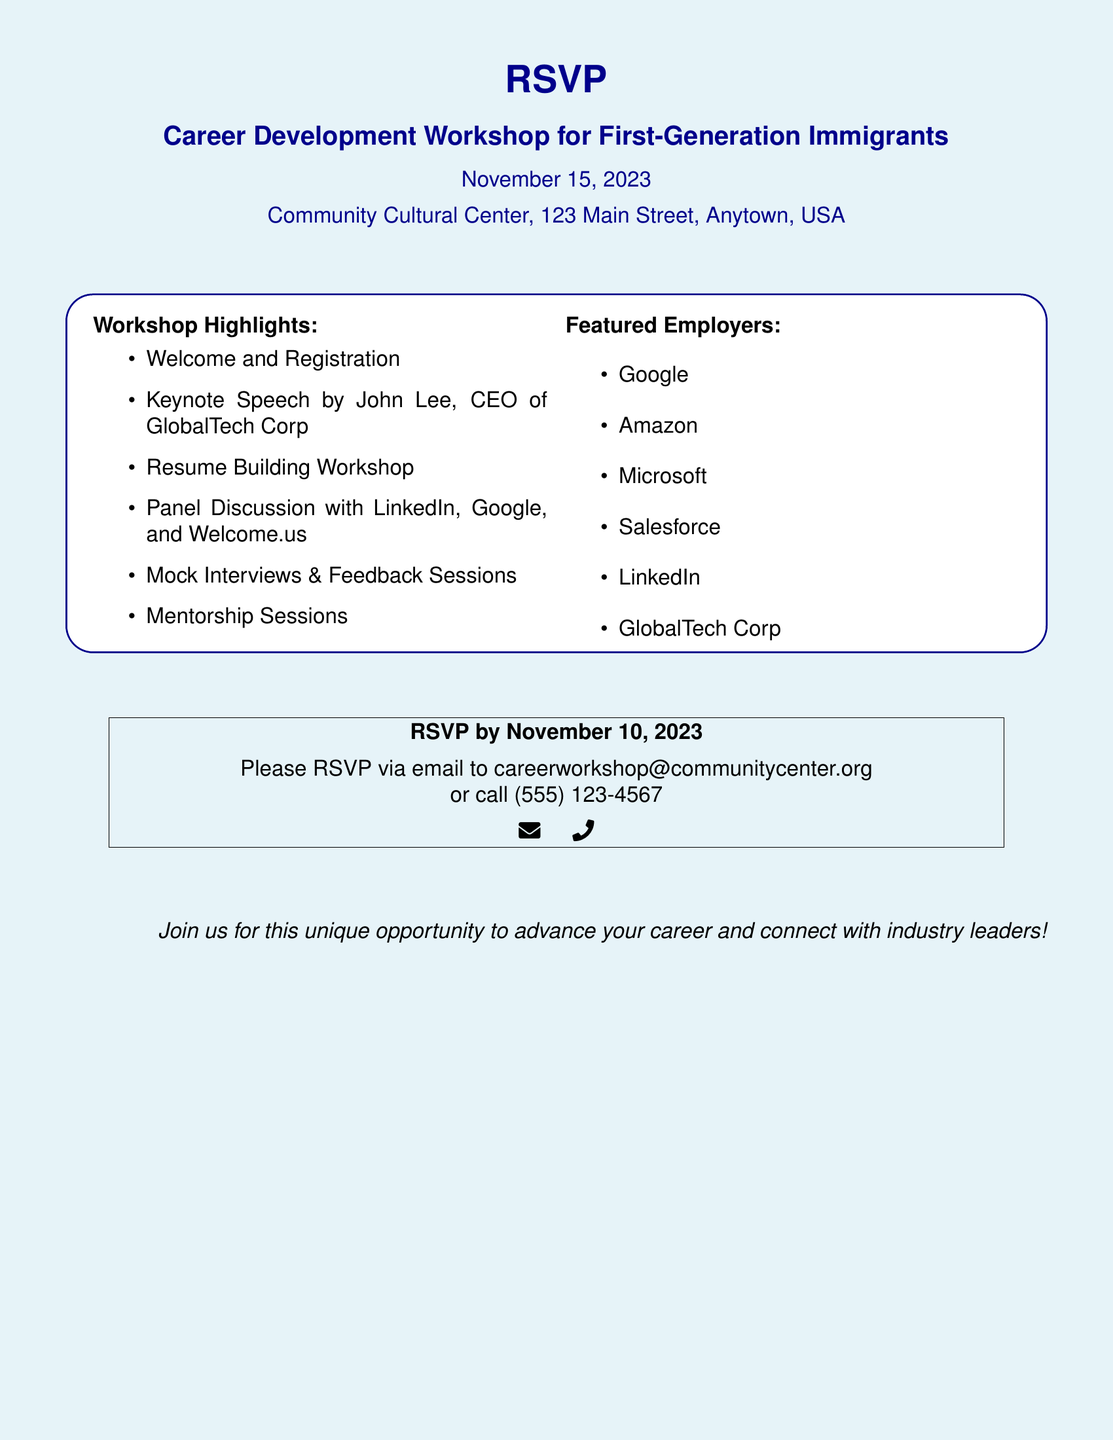What is the date of the workshop? The date of the workshop is clearly mentioned in the document.
Answer: November 15, 2023 What is the location of the event? The location is specified in the document where it lists the address of the community center.
Answer: Community Cultural Center, 123 Main Street, Anytown, USA Who will give the keynote speech? The document includes information about the keynote speaker in the highlights section.
Answer: John Lee How many featured employers are listed? The document provides a list of featured employers which can be counted.
Answer: Six What is the RSVP deadline? The RSVP deadline is provided explicitly in the RSVP section of the document.
Answer: November 10, 2023 Which employer is associated with GlobalTech Corp? The document mentions GlobalTech Corp in the featured employers list.
Answer: GlobalTech Corp What can participants expect to learn from the workshop? The workshop highlights suggest the types of activities attendees can participate in.
Answer: Resume Building Workshop What method can be used to RSVP? The document outlines the contact methods available for RSVPing to the event.
Answer: Email or call 